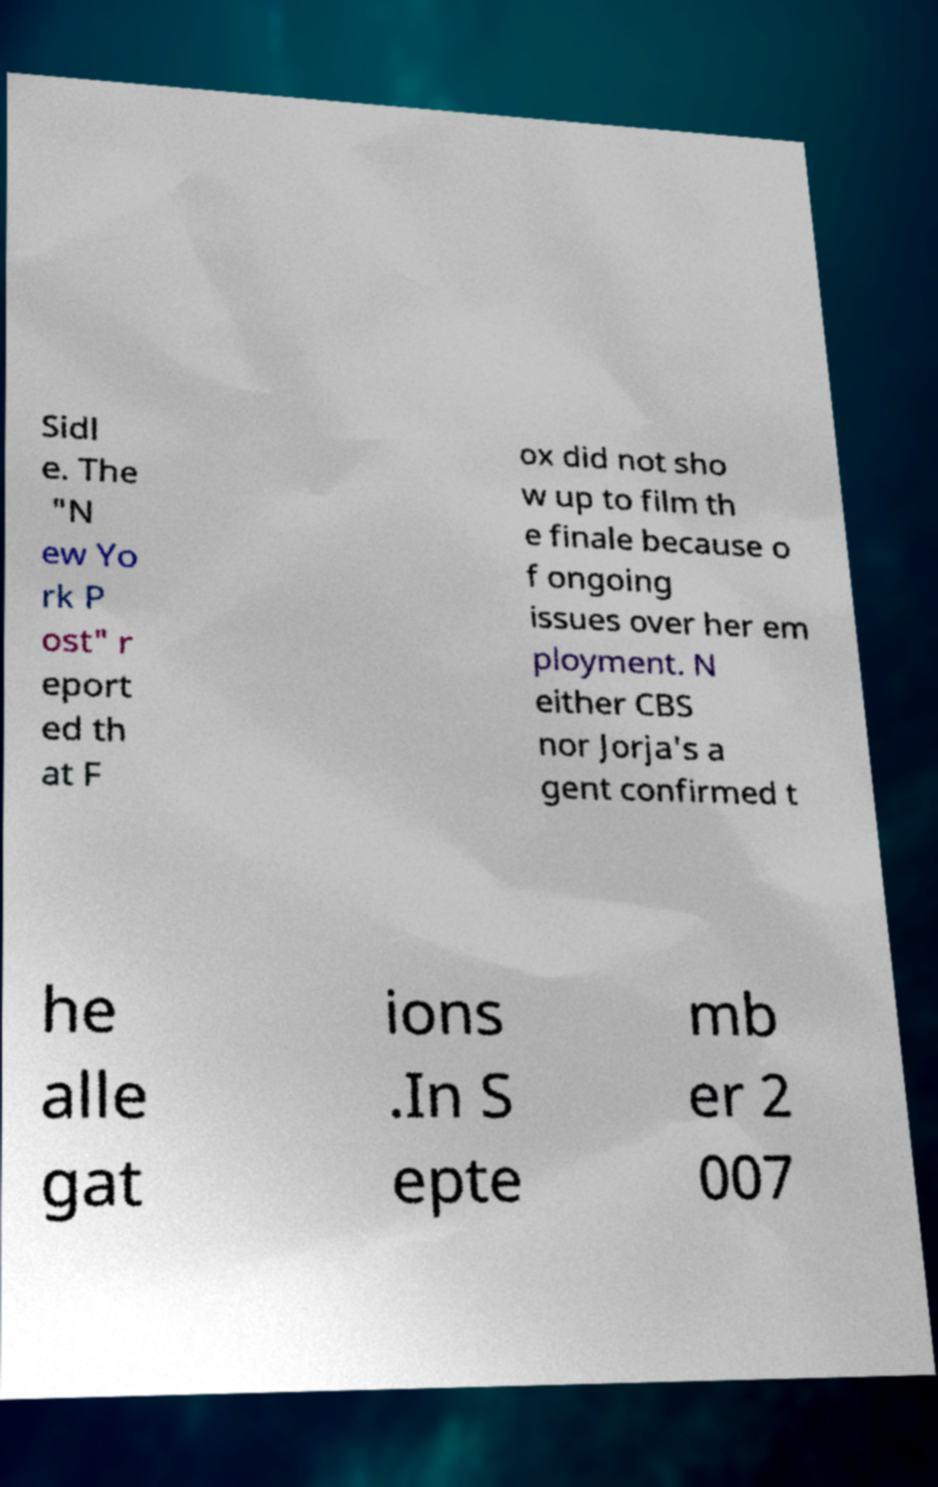Could you assist in decoding the text presented in this image and type it out clearly? Sidl e. The "N ew Yo rk P ost" r eport ed th at F ox did not sho w up to film th e finale because o f ongoing issues over her em ployment. N either CBS nor Jorja's a gent confirmed t he alle gat ions .In S epte mb er 2 007 